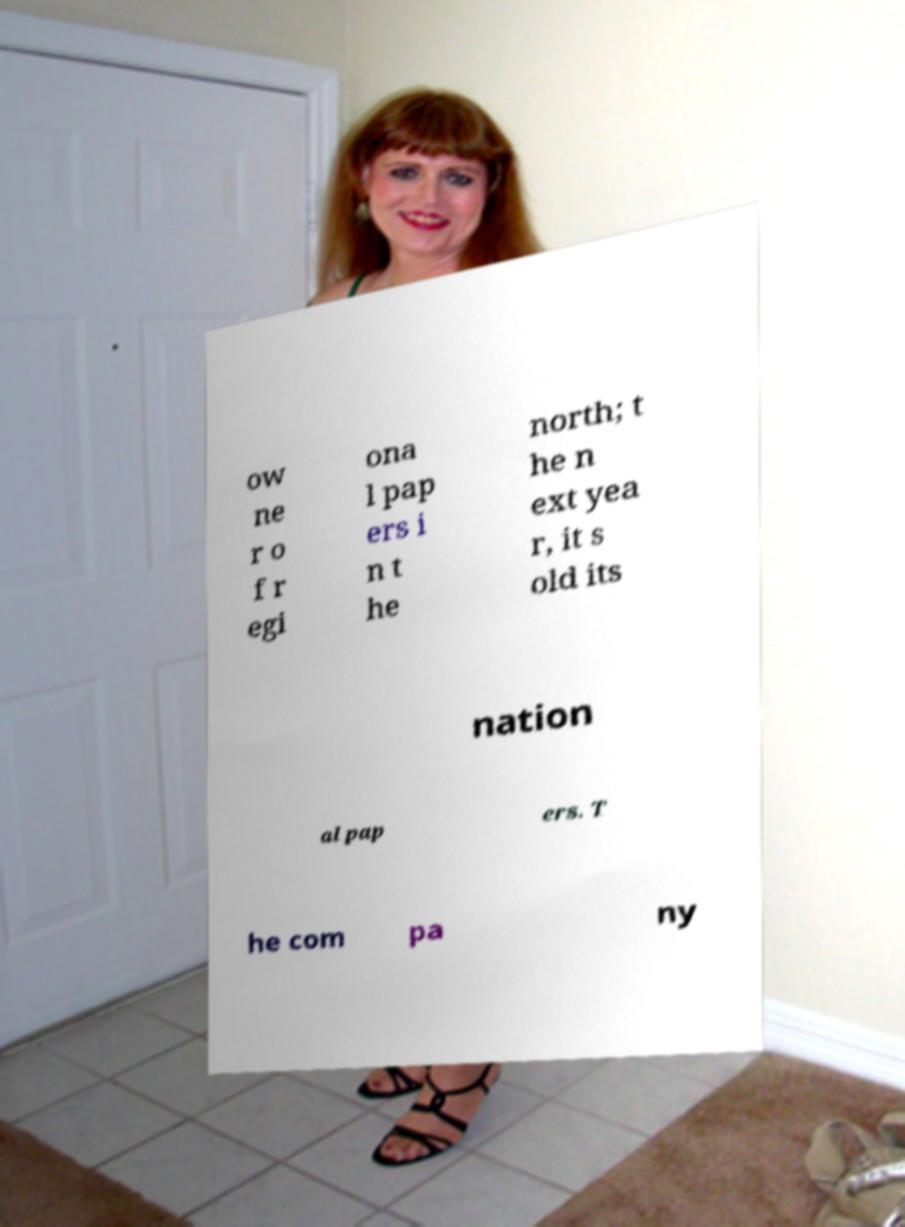What messages or text are displayed in this image? I need them in a readable, typed format. ow ne r o f r egi ona l pap ers i n t he north; t he n ext yea r, it s old its nation al pap ers. T he com pa ny 